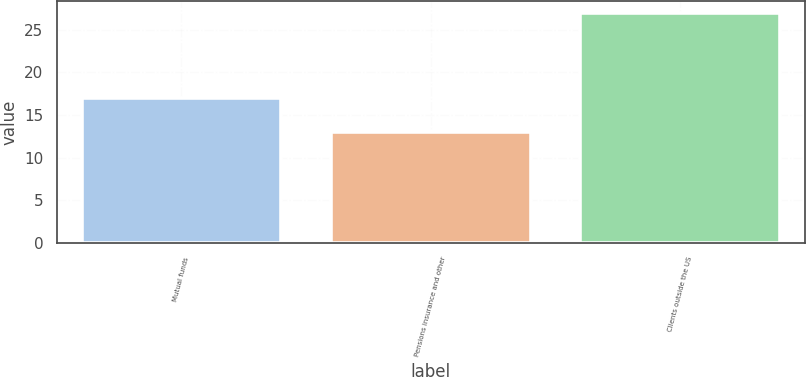Convert chart. <chart><loc_0><loc_0><loc_500><loc_500><bar_chart><fcel>Mutual funds<fcel>Pensions insurance and other<fcel>Clients outside the US<nl><fcel>17<fcel>13<fcel>27<nl></chart> 